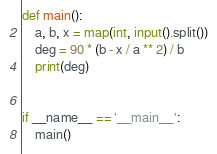Convert code to text. <code><loc_0><loc_0><loc_500><loc_500><_Python_>def main():
    a, b, x = map(int, input().split())
    deg = 90 * (b - x / a ** 2) / b
    print(deg)


if __name__ == '__main__':
    main()</code> 